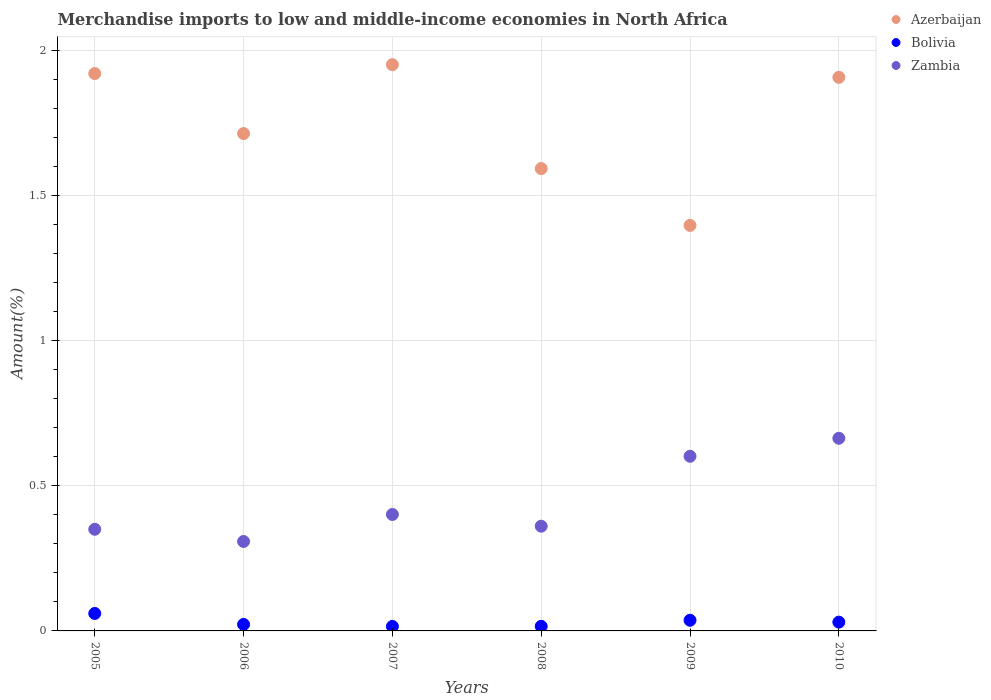What is the percentage of amount earned from merchandise imports in Bolivia in 2005?
Your answer should be compact. 0.06. Across all years, what is the maximum percentage of amount earned from merchandise imports in Azerbaijan?
Ensure brevity in your answer.  1.95. Across all years, what is the minimum percentage of amount earned from merchandise imports in Azerbaijan?
Provide a short and direct response. 1.4. In which year was the percentage of amount earned from merchandise imports in Azerbaijan maximum?
Give a very brief answer. 2007. In which year was the percentage of amount earned from merchandise imports in Azerbaijan minimum?
Your answer should be very brief. 2009. What is the total percentage of amount earned from merchandise imports in Azerbaijan in the graph?
Offer a terse response. 10.48. What is the difference between the percentage of amount earned from merchandise imports in Zambia in 2005 and that in 2006?
Keep it short and to the point. 0.04. What is the difference between the percentage of amount earned from merchandise imports in Bolivia in 2006 and the percentage of amount earned from merchandise imports in Azerbaijan in 2005?
Provide a short and direct response. -1.9. What is the average percentage of amount earned from merchandise imports in Zambia per year?
Your answer should be compact. 0.45. In the year 2009, what is the difference between the percentage of amount earned from merchandise imports in Azerbaijan and percentage of amount earned from merchandise imports in Zambia?
Keep it short and to the point. 0.8. In how many years, is the percentage of amount earned from merchandise imports in Azerbaijan greater than 0.7 %?
Your answer should be compact. 6. What is the ratio of the percentage of amount earned from merchandise imports in Bolivia in 2008 to that in 2010?
Make the answer very short. 0.52. Is the difference between the percentage of amount earned from merchandise imports in Azerbaijan in 2009 and 2010 greater than the difference between the percentage of amount earned from merchandise imports in Zambia in 2009 and 2010?
Offer a terse response. No. What is the difference between the highest and the second highest percentage of amount earned from merchandise imports in Azerbaijan?
Your answer should be very brief. 0.03. What is the difference between the highest and the lowest percentage of amount earned from merchandise imports in Bolivia?
Your response must be concise. 0.04. In how many years, is the percentage of amount earned from merchandise imports in Bolivia greater than the average percentage of amount earned from merchandise imports in Bolivia taken over all years?
Your response must be concise. 3. Is it the case that in every year, the sum of the percentage of amount earned from merchandise imports in Bolivia and percentage of amount earned from merchandise imports in Azerbaijan  is greater than the percentage of amount earned from merchandise imports in Zambia?
Keep it short and to the point. Yes. Does the percentage of amount earned from merchandise imports in Zambia monotonically increase over the years?
Your answer should be very brief. No. Is the percentage of amount earned from merchandise imports in Azerbaijan strictly greater than the percentage of amount earned from merchandise imports in Zambia over the years?
Ensure brevity in your answer.  Yes. Is the percentage of amount earned from merchandise imports in Azerbaijan strictly less than the percentage of amount earned from merchandise imports in Bolivia over the years?
Provide a short and direct response. No. How many dotlines are there?
Your answer should be compact. 3. How many years are there in the graph?
Your answer should be compact. 6. Does the graph contain any zero values?
Give a very brief answer. No. Does the graph contain grids?
Your response must be concise. Yes. How many legend labels are there?
Your response must be concise. 3. What is the title of the graph?
Offer a very short reply. Merchandise imports to low and middle-income economies in North Africa. What is the label or title of the X-axis?
Ensure brevity in your answer.  Years. What is the label or title of the Y-axis?
Your answer should be compact. Amount(%). What is the Amount(%) of Azerbaijan in 2005?
Your response must be concise. 1.92. What is the Amount(%) in Bolivia in 2005?
Offer a very short reply. 0.06. What is the Amount(%) of Zambia in 2005?
Your answer should be compact. 0.35. What is the Amount(%) of Azerbaijan in 2006?
Make the answer very short. 1.71. What is the Amount(%) of Bolivia in 2006?
Your answer should be very brief. 0.02. What is the Amount(%) of Zambia in 2006?
Provide a short and direct response. 0.31. What is the Amount(%) of Azerbaijan in 2007?
Ensure brevity in your answer.  1.95. What is the Amount(%) of Bolivia in 2007?
Provide a short and direct response. 0.02. What is the Amount(%) of Zambia in 2007?
Provide a succinct answer. 0.4. What is the Amount(%) in Azerbaijan in 2008?
Your answer should be very brief. 1.59. What is the Amount(%) of Bolivia in 2008?
Ensure brevity in your answer.  0.02. What is the Amount(%) in Zambia in 2008?
Ensure brevity in your answer.  0.36. What is the Amount(%) of Azerbaijan in 2009?
Your answer should be very brief. 1.4. What is the Amount(%) of Bolivia in 2009?
Offer a very short reply. 0.04. What is the Amount(%) of Zambia in 2009?
Ensure brevity in your answer.  0.6. What is the Amount(%) in Azerbaijan in 2010?
Provide a short and direct response. 1.91. What is the Amount(%) of Bolivia in 2010?
Offer a very short reply. 0.03. What is the Amount(%) in Zambia in 2010?
Offer a terse response. 0.66. Across all years, what is the maximum Amount(%) in Azerbaijan?
Keep it short and to the point. 1.95. Across all years, what is the maximum Amount(%) of Bolivia?
Give a very brief answer. 0.06. Across all years, what is the maximum Amount(%) in Zambia?
Your response must be concise. 0.66. Across all years, what is the minimum Amount(%) in Azerbaijan?
Ensure brevity in your answer.  1.4. Across all years, what is the minimum Amount(%) in Bolivia?
Offer a terse response. 0.02. Across all years, what is the minimum Amount(%) of Zambia?
Your answer should be very brief. 0.31. What is the total Amount(%) of Azerbaijan in the graph?
Your response must be concise. 10.48. What is the total Amount(%) of Bolivia in the graph?
Provide a short and direct response. 0.18. What is the total Amount(%) of Zambia in the graph?
Give a very brief answer. 2.69. What is the difference between the Amount(%) of Azerbaijan in 2005 and that in 2006?
Your answer should be compact. 0.21. What is the difference between the Amount(%) in Bolivia in 2005 and that in 2006?
Ensure brevity in your answer.  0.04. What is the difference between the Amount(%) of Zambia in 2005 and that in 2006?
Make the answer very short. 0.04. What is the difference between the Amount(%) of Azerbaijan in 2005 and that in 2007?
Give a very brief answer. -0.03. What is the difference between the Amount(%) of Bolivia in 2005 and that in 2007?
Make the answer very short. 0.04. What is the difference between the Amount(%) of Zambia in 2005 and that in 2007?
Keep it short and to the point. -0.05. What is the difference between the Amount(%) of Azerbaijan in 2005 and that in 2008?
Offer a terse response. 0.33. What is the difference between the Amount(%) in Bolivia in 2005 and that in 2008?
Provide a short and direct response. 0.04. What is the difference between the Amount(%) in Zambia in 2005 and that in 2008?
Ensure brevity in your answer.  -0.01. What is the difference between the Amount(%) of Azerbaijan in 2005 and that in 2009?
Your response must be concise. 0.52. What is the difference between the Amount(%) in Bolivia in 2005 and that in 2009?
Your answer should be compact. 0.02. What is the difference between the Amount(%) in Zambia in 2005 and that in 2009?
Ensure brevity in your answer.  -0.25. What is the difference between the Amount(%) of Azerbaijan in 2005 and that in 2010?
Ensure brevity in your answer.  0.01. What is the difference between the Amount(%) of Bolivia in 2005 and that in 2010?
Keep it short and to the point. 0.03. What is the difference between the Amount(%) of Zambia in 2005 and that in 2010?
Offer a terse response. -0.31. What is the difference between the Amount(%) in Azerbaijan in 2006 and that in 2007?
Give a very brief answer. -0.24. What is the difference between the Amount(%) in Bolivia in 2006 and that in 2007?
Your answer should be very brief. 0.01. What is the difference between the Amount(%) in Zambia in 2006 and that in 2007?
Your answer should be compact. -0.09. What is the difference between the Amount(%) of Azerbaijan in 2006 and that in 2008?
Your answer should be compact. 0.12. What is the difference between the Amount(%) in Bolivia in 2006 and that in 2008?
Provide a succinct answer. 0.01. What is the difference between the Amount(%) in Zambia in 2006 and that in 2008?
Offer a terse response. -0.05. What is the difference between the Amount(%) of Azerbaijan in 2006 and that in 2009?
Ensure brevity in your answer.  0.32. What is the difference between the Amount(%) of Bolivia in 2006 and that in 2009?
Give a very brief answer. -0.01. What is the difference between the Amount(%) of Zambia in 2006 and that in 2009?
Offer a terse response. -0.29. What is the difference between the Amount(%) in Azerbaijan in 2006 and that in 2010?
Provide a short and direct response. -0.19. What is the difference between the Amount(%) in Bolivia in 2006 and that in 2010?
Your answer should be compact. -0.01. What is the difference between the Amount(%) in Zambia in 2006 and that in 2010?
Keep it short and to the point. -0.36. What is the difference between the Amount(%) in Azerbaijan in 2007 and that in 2008?
Offer a very short reply. 0.36. What is the difference between the Amount(%) of Bolivia in 2007 and that in 2008?
Your response must be concise. -0. What is the difference between the Amount(%) of Zambia in 2007 and that in 2008?
Ensure brevity in your answer.  0.04. What is the difference between the Amount(%) in Azerbaijan in 2007 and that in 2009?
Your answer should be compact. 0.55. What is the difference between the Amount(%) of Bolivia in 2007 and that in 2009?
Your response must be concise. -0.02. What is the difference between the Amount(%) in Zambia in 2007 and that in 2009?
Keep it short and to the point. -0.2. What is the difference between the Amount(%) of Azerbaijan in 2007 and that in 2010?
Your answer should be very brief. 0.04. What is the difference between the Amount(%) in Bolivia in 2007 and that in 2010?
Provide a succinct answer. -0.01. What is the difference between the Amount(%) of Zambia in 2007 and that in 2010?
Your answer should be compact. -0.26. What is the difference between the Amount(%) in Azerbaijan in 2008 and that in 2009?
Provide a succinct answer. 0.2. What is the difference between the Amount(%) of Bolivia in 2008 and that in 2009?
Provide a succinct answer. -0.02. What is the difference between the Amount(%) in Zambia in 2008 and that in 2009?
Ensure brevity in your answer.  -0.24. What is the difference between the Amount(%) in Azerbaijan in 2008 and that in 2010?
Provide a succinct answer. -0.31. What is the difference between the Amount(%) in Bolivia in 2008 and that in 2010?
Give a very brief answer. -0.01. What is the difference between the Amount(%) of Zambia in 2008 and that in 2010?
Your answer should be very brief. -0.3. What is the difference between the Amount(%) in Azerbaijan in 2009 and that in 2010?
Ensure brevity in your answer.  -0.51. What is the difference between the Amount(%) of Bolivia in 2009 and that in 2010?
Keep it short and to the point. 0.01. What is the difference between the Amount(%) of Zambia in 2009 and that in 2010?
Provide a short and direct response. -0.06. What is the difference between the Amount(%) in Azerbaijan in 2005 and the Amount(%) in Bolivia in 2006?
Offer a terse response. 1.9. What is the difference between the Amount(%) in Azerbaijan in 2005 and the Amount(%) in Zambia in 2006?
Keep it short and to the point. 1.61. What is the difference between the Amount(%) of Bolivia in 2005 and the Amount(%) of Zambia in 2006?
Ensure brevity in your answer.  -0.25. What is the difference between the Amount(%) of Azerbaijan in 2005 and the Amount(%) of Bolivia in 2007?
Provide a succinct answer. 1.91. What is the difference between the Amount(%) of Azerbaijan in 2005 and the Amount(%) of Zambia in 2007?
Your answer should be compact. 1.52. What is the difference between the Amount(%) of Bolivia in 2005 and the Amount(%) of Zambia in 2007?
Ensure brevity in your answer.  -0.34. What is the difference between the Amount(%) of Azerbaijan in 2005 and the Amount(%) of Bolivia in 2008?
Offer a very short reply. 1.9. What is the difference between the Amount(%) of Azerbaijan in 2005 and the Amount(%) of Zambia in 2008?
Your answer should be compact. 1.56. What is the difference between the Amount(%) in Bolivia in 2005 and the Amount(%) in Zambia in 2008?
Your response must be concise. -0.3. What is the difference between the Amount(%) of Azerbaijan in 2005 and the Amount(%) of Bolivia in 2009?
Provide a succinct answer. 1.88. What is the difference between the Amount(%) of Azerbaijan in 2005 and the Amount(%) of Zambia in 2009?
Give a very brief answer. 1.32. What is the difference between the Amount(%) in Bolivia in 2005 and the Amount(%) in Zambia in 2009?
Provide a short and direct response. -0.54. What is the difference between the Amount(%) of Azerbaijan in 2005 and the Amount(%) of Bolivia in 2010?
Offer a terse response. 1.89. What is the difference between the Amount(%) of Azerbaijan in 2005 and the Amount(%) of Zambia in 2010?
Offer a terse response. 1.26. What is the difference between the Amount(%) of Bolivia in 2005 and the Amount(%) of Zambia in 2010?
Keep it short and to the point. -0.6. What is the difference between the Amount(%) of Azerbaijan in 2006 and the Amount(%) of Bolivia in 2007?
Ensure brevity in your answer.  1.7. What is the difference between the Amount(%) in Azerbaijan in 2006 and the Amount(%) in Zambia in 2007?
Provide a succinct answer. 1.31. What is the difference between the Amount(%) in Bolivia in 2006 and the Amount(%) in Zambia in 2007?
Offer a very short reply. -0.38. What is the difference between the Amount(%) of Azerbaijan in 2006 and the Amount(%) of Bolivia in 2008?
Your answer should be very brief. 1.7. What is the difference between the Amount(%) of Azerbaijan in 2006 and the Amount(%) of Zambia in 2008?
Provide a short and direct response. 1.35. What is the difference between the Amount(%) of Bolivia in 2006 and the Amount(%) of Zambia in 2008?
Provide a short and direct response. -0.34. What is the difference between the Amount(%) of Azerbaijan in 2006 and the Amount(%) of Bolivia in 2009?
Keep it short and to the point. 1.68. What is the difference between the Amount(%) of Azerbaijan in 2006 and the Amount(%) of Zambia in 2009?
Provide a succinct answer. 1.11. What is the difference between the Amount(%) in Bolivia in 2006 and the Amount(%) in Zambia in 2009?
Your response must be concise. -0.58. What is the difference between the Amount(%) in Azerbaijan in 2006 and the Amount(%) in Bolivia in 2010?
Give a very brief answer. 1.68. What is the difference between the Amount(%) of Bolivia in 2006 and the Amount(%) of Zambia in 2010?
Give a very brief answer. -0.64. What is the difference between the Amount(%) in Azerbaijan in 2007 and the Amount(%) in Bolivia in 2008?
Keep it short and to the point. 1.94. What is the difference between the Amount(%) of Azerbaijan in 2007 and the Amount(%) of Zambia in 2008?
Provide a succinct answer. 1.59. What is the difference between the Amount(%) in Bolivia in 2007 and the Amount(%) in Zambia in 2008?
Your response must be concise. -0.35. What is the difference between the Amount(%) of Azerbaijan in 2007 and the Amount(%) of Bolivia in 2009?
Keep it short and to the point. 1.91. What is the difference between the Amount(%) in Azerbaijan in 2007 and the Amount(%) in Zambia in 2009?
Give a very brief answer. 1.35. What is the difference between the Amount(%) in Bolivia in 2007 and the Amount(%) in Zambia in 2009?
Make the answer very short. -0.59. What is the difference between the Amount(%) in Azerbaijan in 2007 and the Amount(%) in Bolivia in 2010?
Keep it short and to the point. 1.92. What is the difference between the Amount(%) of Azerbaijan in 2007 and the Amount(%) of Zambia in 2010?
Your answer should be compact. 1.29. What is the difference between the Amount(%) in Bolivia in 2007 and the Amount(%) in Zambia in 2010?
Your answer should be compact. -0.65. What is the difference between the Amount(%) of Azerbaijan in 2008 and the Amount(%) of Bolivia in 2009?
Your response must be concise. 1.56. What is the difference between the Amount(%) in Azerbaijan in 2008 and the Amount(%) in Zambia in 2009?
Ensure brevity in your answer.  0.99. What is the difference between the Amount(%) in Bolivia in 2008 and the Amount(%) in Zambia in 2009?
Your answer should be very brief. -0.59. What is the difference between the Amount(%) in Azerbaijan in 2008 and the Amount(%) in Bolivia in 2010?
Keep it short and to the point. 1.56. What is the difference between the Amount(%) in Azerbaijan in 2008 and the Amount(%) in Zambia in 2010?
Your answer should be very brief. 0.93. What is the difference between the Amount(%) in Bolivia in 2008 and the Amount(%) in Zambia in 2010?
Give a very brief answer. -0.65. What is the difference between the Amount(%) in Azerbaijan in 2009 and the Amount(%) in Bolivia in 2010?
Offer a very short reply. 1.37. What is the difference between the Amount(%) in Azerbaijan in 2009 and the Amount(%) in Zambia in 2010?
Give a very brief answer. 0.73. What is the difference between the Amount(%) of Bolivia in 2009 and the Amount(%) of Zambia in 2010?
Make the answer very short. -0.63. What is the average Amount(%) of Azerbaijan per year?
Give a very brief answer. 1.75. What is the average Amount(%) in Bolivia per year?
Your response must be concise. 0.03. What is the average Amount(%) of Zambia per year?
Offer a very short reply. 0.45. In the year 2005, what is the difference between the Amount(%) of Azerbaijan and Amount(%) of Bolivia?
Provide a succinct answer. 1.86. In the year 2005, what is the difference between the Amount(%) in Azerbaijan and Amount(%) in Zambia?
Your response must be concise. 1.57. In the year 2005, what is the difference between the Amount(%) in Bolivia and Amount(%) in Zambia?
Your answer should be compact. -0.29. In the year 2006, what is the difference between the Amount(%) in Azerbaijan and Amount(%) in Bolivia?
Offer a terse response. 1.69. In the year 2006, what is the difference between the Amount(%) in Azerbaijan and Amount(%) in Zambia?
Your answer should be compact. 1.41. In the year 2006, what is the difference between the Amount(%) in Bolivia and Amount(%) in Zambia?
Your answer should be compact. -0.29. In the year 2007, what is the difference between the Amount(%) in Azerbaijan and Amount(%) in Bolivia?
Offer a terse response. 1.94. In the year 2007, what is the difference between the Amount(%) in Azerbaijan and Amount(%) in Zambia?
Keep it short and to the point. 1.55. In the year 2007, what is the difference between the Amount(%) of Bolivia and Amount(%) of Zambia?
Your answer should be compact. -0.39. In the year 2008, what is the difference between the Amount(%) in Azerbaijan and Amount(%) in Bolivia?
Keep it short and to the point. 1.58. In the year 2008, what is the difference between the Amount(%) of Azerbaijan and Amount(%) of Zambia?
Give a very brief answer. 1.23. In the year 2008, what is the difference between the Amount(%) of Bolivia and Amount(%) of Zambia?
Provide a short and direct response. -0.34. In the year 2009, what is the difference between the Amount(%) of Azerbaijan and Amount(%) of Bolivia?
Provide a succinct answer. 1.36. In the year 2009, what is the difference between the Amount(%) in Azerbaijan and Amount(%) in Zambia?
Offer a very short reply. 0.8. In the year 2009, what is the difference between the Amount(%) in Bolivia and Amount(%) in Zambia?
Provide a succinct answer. -0.57. In the year 2010, what is the difference between the Amount(%) of Azerbaijan and Amount(%) of Bolivia?
Make the answer very short. 1.88. In the year 2010, what is the difference between the Amount(%) in Azerbaijan and Amount(%) in Zambia?
Offer a terse response. 1.24. In the year 2010, what is the difference between the Amount(%) in Bolivia and Amount(%) in Zambia?
Give a very brief answer. -0.63. What is the ratio of the Amount(%) in Azerbaijan in 2005 to that in 2006?
Your answer should be compact. 1.12. What is the ratio of the Amount(%) in Bolivia in 2005 to that in 2006?
Make the answer very short. 2.68. What is the ratio of the Amount(%) of Zambia in 2005 to that in 2006?
Provide a short and direct response. 1.14. What is the ratio of the Amount(%) in Azerbaijan in 2005 to that in 2007?
Give a very brief answer. 0.98. What is the ratio of the Amount(%) in Bolivia in 2005 to that in 2007?
Your response must be concise. 3.89. What is the ratio of the Amount(%) of Zambia in 2005 to that in 2007?
Your answer should be very brief. 0.87. What is the ratio of the Amount(%) in Azerbaijan in 2005 to that in 2008?
Your response must be concise. 1.21. What is the ratio of the Amount(%) of Bolivia in 2005 to that in 2008?
Offer a very short reply. 3.79. What is the ratio of the Amount(%) in Zambia in 2005 to that in 2008?
Keep it short and to the point. 0.97. What is the ratio of the Amount(%) in Azerbaijan in 2005 to that in 2009?
Ensure brevity in your answer.  1.37. What is the ratio of the Amount(%) in Bolivia in 2005 to that in 2009?
Give a very brief answer. 1.64. What is the ratio of the Amount(%) in Zambia in 2005 to that in 2009?
Offer a very short reply. 0.58. What is the ratio of the Amount(%) in Azerbaijan in 2005 to that in 2010?
Make the answer very short. 1.01. What is the ratio of the Amount(%) in Bolivia in 2005 to that in 2010?
Ensure brevity in your answer.  1.99. What is the ratio of the Amount(%) in Zambia in 2005 to that in 2010?
Your answer should be compact. 0.53. What is the ratio of the Amount(%) in Azerbaijan in 2006 to that in 2007?
Provide a short and direct response. 0.88. What is the ratio of the Amount(%) of Bolivia in 2006 to that in 2007?
Your answer should be very brief. 1.45. What is the ratio of the Amount(%) in Zambia in 2006 to that in 2007?
Provide a succinct answer. 0.77. What is the ratio of the Amount(%) of Azerbaijan in 2006 to that in 2008?
Give a very brief answer. 1.08. What is the ratio of the Amount(%) of Bolivia in 2006 to that in 2008?
Provide a short and direct response. 1.41. What is the ratio of the Amount(%) of Zambia in 2006 to that in 2008?
Keep it short and to the point. 0.85. What is the ratio of the Amount(%) in Azerbaijan in 2006 to that in 2009?
Your answer should be compact. 1.23. What is the ratio of the Amount(%) in Bolivia in 2006 to that in 2009?
Offer a very short reply. 0.61. What is the ratio of the Amount(%) of Zambia in 2006 to that in 2009?
Keep it short and to the point. 0.51. What is the ratio of the Amount(%) in Azerbaijan in 2006 to that in 2010?
Your answer should be very brief. 0.9. What is the ratio of the Amount(%) in Bolivia in 2006 to that in 2010?
Give a very brief answer. 0.74. What is the ratio of the Amount(%) of Zambia in 2006 to that in 2010?
Your response must be concise. 0.46. What is the ratio of the Amount(%) in Azerbaijan in 2007 to that in 2008?
Give a very brief answer. 1.22. What is the ratio of the Amount(%) in Bolivia in 2007 to that in 2008?
Give a very brief answer. 0.97. What is the ratio of the Amount(%) of Zambia in 2007 to that in 2008?
Provide a succinct answer. 1.11. What is the ratio of the Amount(%) of Azerbaijan in 2007 to that in 2009?
Your answer should be very brief. 1.4. What is the ratio of the Amount(%) in Bolivia in 2007 to that in 2009?
Give a very brief answer. 0.42. What is the ratio of the Amount(%) in Azerbaijan in 2007 to that in 2010?
Provide a succinct answer. 1.02. What is the ratio of the Amount(%) in Bolivia in 2007 to that in 2010?
Provide a succinct answer. 0.51. What is the ratio of the Amount(%) of Zambia in 2007 to that in 2010?
Give a very brief answer. 0.6. What is the ratio of the Amount(%) in Azerbaijan in 2008 to that in 2009?
Give a very brief answer. 1.14. What is the ratio of the Amount(%) in Bolivia in 2008 to that in 2009?
Your response must be concise. 0.43. What is the ratio of the Amount(%) of Zambia in 2008 to that in 2009?
Your answer should be compact. 0.6. What is the ratio of the Amount(%) of Azerbaijan in 2008 to that in 2010?
Provide a short and direct response. 0.84. What is the ratio of the Amount(%) of Bolivia in 2008 to that in 2010?
Offer a very short reply. 0.52. What is the ratio of the Amount(%) in Zambia in 2008 to that in 2010?
Your response must be concise. 0.54. What is the ratio of the Amount(%) of Azerbaijan in 2009 to that in 2010?
Keep it short and to the point. 0.73. What is the ratio of the Amount(%) in Bolivia in 2009 to that in 2010?
Keep it short and to the point. 1.21. What is the ratio of the Amount(%) in Zambia in 2009 to that in 2010?
Keep it short and to the point. 0.91. What is the difference between the highest and the second highest Amount(%) of Azerbaijan?
Your response must be concise. 0.03. What is the difference between the highest and the second highest Amount(%) of Bolivia?
Provide a short and direct response. 0.02. What is the difference between the highest and the second highest Amount(%) of Zambia?
Your answer should be very brief. 0.06. What is the difference between the highest and the lowest Amount(%) of Azerbaijan?
Your response must be concise. 0.55. What is the difference between the highest and the lowest Amount(%) of Bolivia?
Ensure brevity in your answer.  0.04. What is the difference between the highest and the lowest Amount(%) of Zambia?
Ensure brevity in your answer.  0.36. 